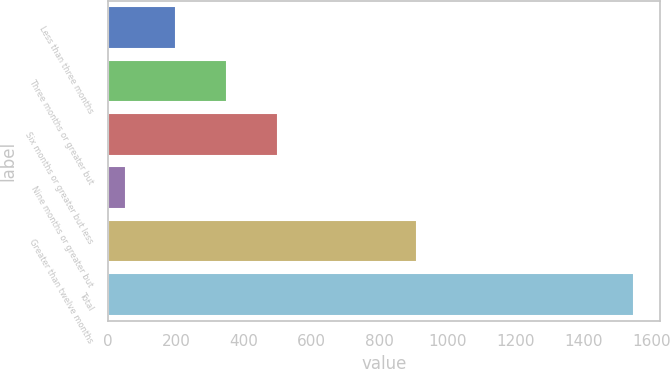Convert chart. <chart><loc_0><loc_0><loc_500><loc_500><bar_chart><fcel>Less than three months<fcel>Three months or greater but<fcel>Six months or greater but less<fcel>Nine months or greater but<fcel>Greater than twelve months<fcel>Total<nl><fcel>201.6<fcel>351.2<fcel>500.8<fcel>52<fcel>908<fcel>1548<nl></chart> 